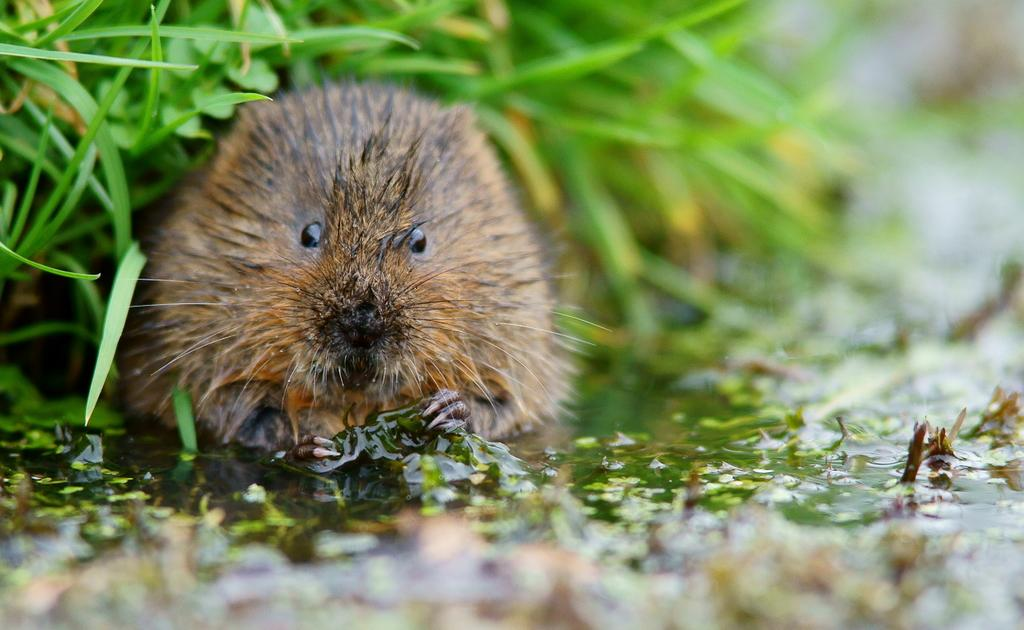What animal is present in the image? There is a rat in the picture. Where is the rat located in relation to the water? The rat is near the water. What type of vegetation is present in the water? There are water plants in the water. What can be seen in the background of the image? There is a grass plant in the background of the image. What is the rate of the toe in the image? There is no toe present in the image, and therefore no rate can be determined. 